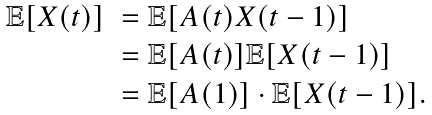Convert formula to latex. <formula><loc_0><loc_0><loc_500><loc_500>\begin{array} { l l } \mathbb { E } [ X ( t ) ] & = \mathbb { E } [ A ( t ) X ( t - 1 ) ] \\ & = \mathbb { E } [ A ( t ) ] \mathbb { E } [ X ( t - 1 ) ] \\ & = \mathbb { E } [ A ( 1 ) ] \cdot \mathbb { E } [ X ( t - 1 ) ] . \end{array}</formula> 